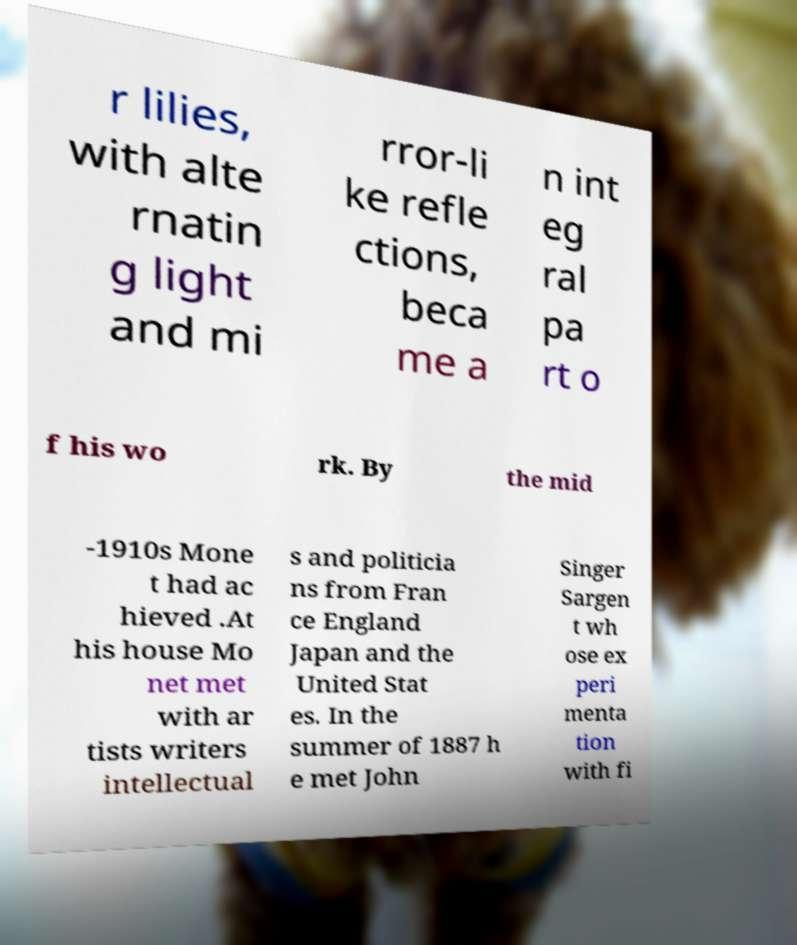Can you read and provide the text displayed in the image?This photo seems to have some interesting text. Can you extract and type it out for me? r lilies, with alte rnatin g light and mi rror-li ke refle ctions, beca me a n int eg ral pa rt o f his wo rk. By the mid -1910s Mone t had ac hieved .At his house Mo net met with ar tists writers intellectual s and politicia ns from Fran ce England Japan and the United Stat es. In the summer of 1887 h e met John Singer Sargen t wh ose ex peri menta tion with fi 